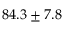<formula> <loc_0><loc_0><loc_500><loc_500>8 4 . 3 \pm 7 . 8</formula> 